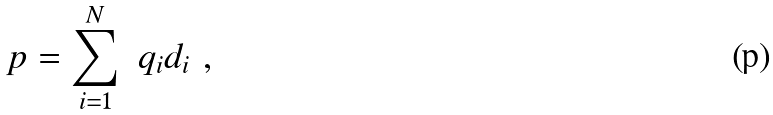Convert formula to latex. <formula><loc_0><loc_0><loc_500><loc_500>p = \sum _ { i = 1 } ^ { N } \ q _ { i } d _ { i } \ ,</formula> 